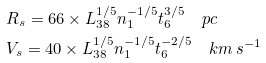Convert formula to latex. <formula><loc_0><loc_0><loc_500><loc_500>& R _ { s } = 6 6 \times L _ { 3 8 } ^ { 1 / 5 } n _ { 1 } ^ { - 1 / 5 } t _ { 6 } ^ { 3 / 5 } \quad p c \\ & V _ { s } = 4 0 \times L _ { 3 8 } ^ { 1 / 5 } n _ { 1 } ^ { - 1 / 5 } t _ { 6 } ^ { - 2 / 5 } \quad k m \, s ^ { - 1 }</formula> 